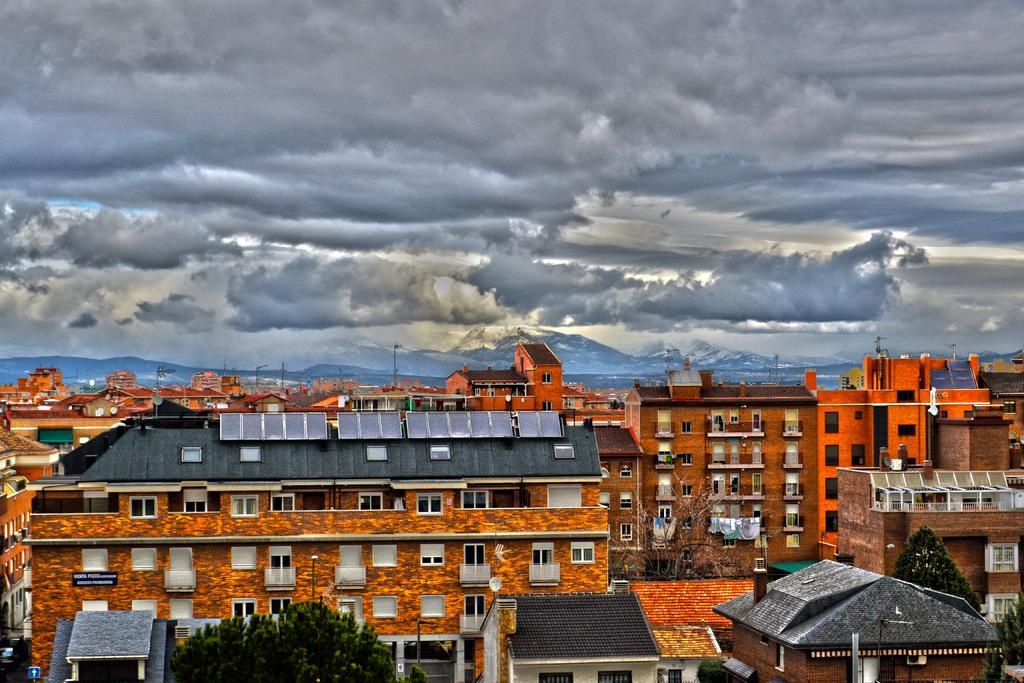What type of structures are present in the image? There are many buildings with windows in the image. What other natural elements can be seen in the image? There are trees in the image. What is visible in the background of the image? The sky with clouds and mountains are visible in the background of the image. Where is the dock located in the image? There is no dock present in the image. Can you describe the servant's attire in the image? There are no servants present in the image. 